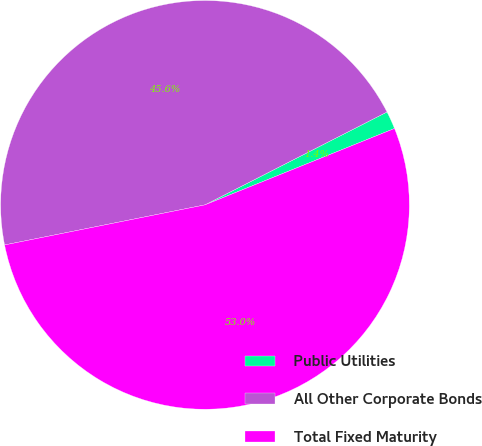Convert chart to OTSL. <chart><loc_0><loc_0><loc_500><loc_500><pie_chart><fcel>Public Utilities<fcel>All Other Corporate Bonds<fcel>Total Fixed Maturity<nl><fcel>1.41%<fcel>45.63%<fcel>52.95%<nl></chart> 